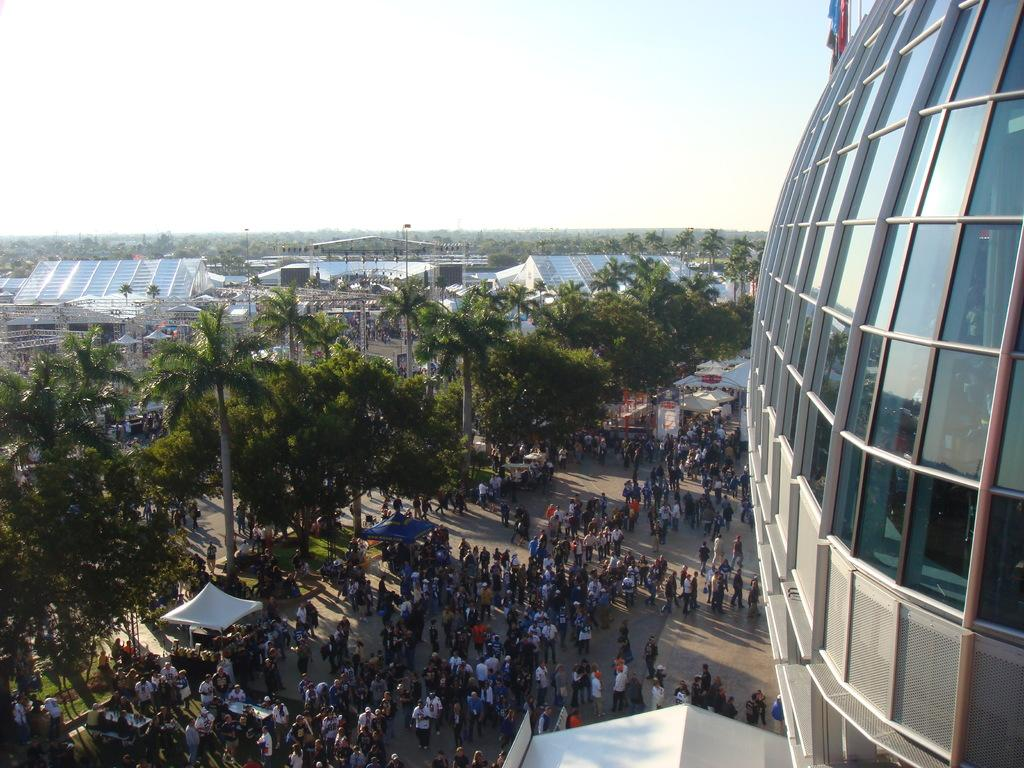What can be seen in the image in terms of human presence? There are people standing in the image. What type of temporary shelters are visible in the image? There are tents in the image. What type of natural vegetation is present in the image? There are trees in the image. What type of permanent structures are visible in the image? There are buildings in the image. What can be observed about the lighting conditions in the image? Shadows are visible in the image. What type of honey is being used to light the lamp in the image? There is no lamp or honey present in the image. What type of memory is being stored in the buildings in the image? There is no reference to memory storage in the image; the buildings are simply structures. 